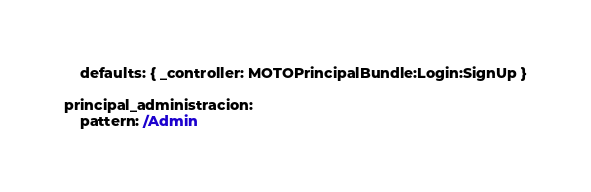Convert code to text. <code><loc_0><loc_0><loc_500><loc_500><_YAML_>    defaults: { _controller: MOTOPrincipalBundle:Login:SignUp }

principal_administracion:
    pattern: /Admin</code> 